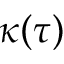Convert formula to latex. <formula><loc_0><loc_0><loc_500><loc_500>\kappa ( \tau )</formula> 